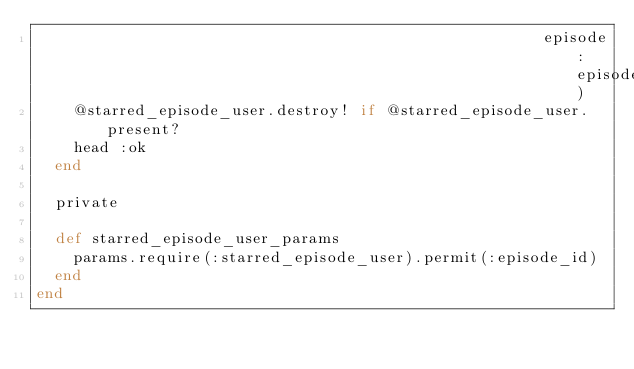Convert code to text. <code><loc_0><loc_0><loc_500><loc_500><_Ruby_>                                                       episode: episode)
    @starred_episode_user.destroy! if @starred_episode_user.present?
    head :ok
  end

  private

  def starred_episode_user_params
    params.require(:starred_episode_user).permit(:episode_id)
  end
end
</code> 